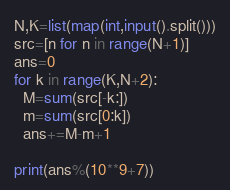Convert code to text. <code><loc_0><loc_0><loc_500><loc_500><_Python_>N,K=list(map(int,input().split()))
src=[n for n in range(N+1)]
ans=0
for k in range(K,N+2):
  M=sum(src[-k:])
  m=sum(src[0:k])
  ans+=M-m+1

print(ans%(10**9+7))</code> 